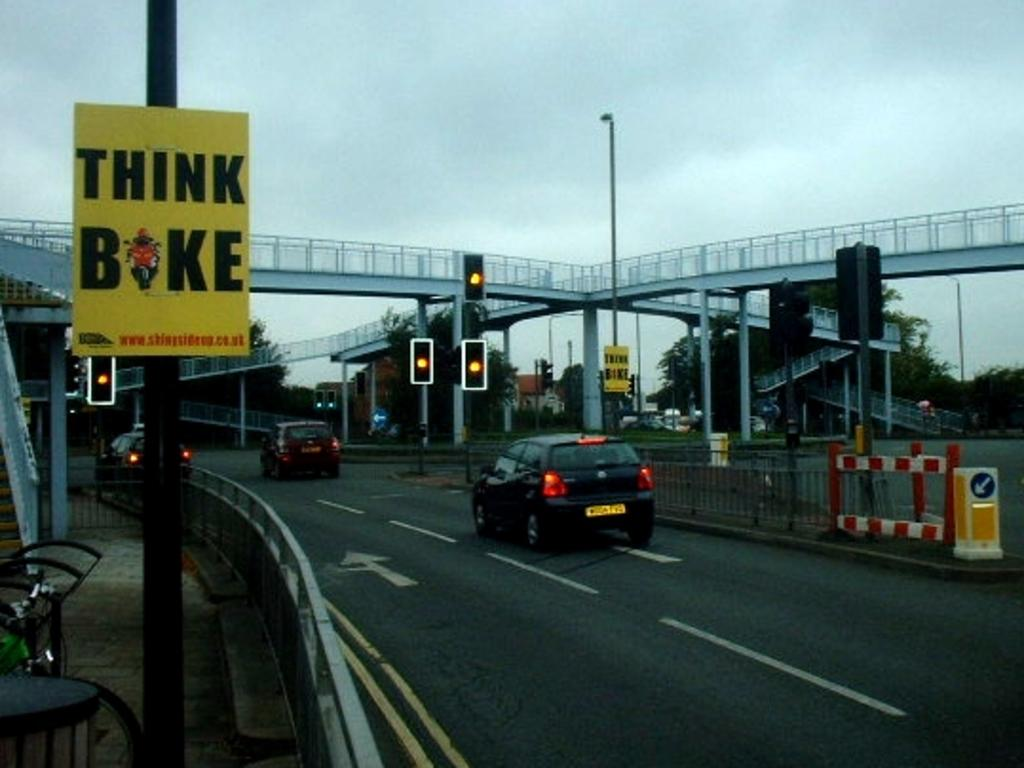What is the main feature of the image? There is a road in the image. What can be seen on the road? There are cars on the road. What structures are present in the image? There are poles, boards, and traffic lights in the image. What type of vegetation is visible in the image? There are trees in the image. What architectural feature is at the top of the image? There is a bridge at the top of the image. What is visible in the sky? The sky is visible at the top of the image. What type of coil can be seen on the bridge in the image? There is no coil present on the bridge in the image. How many spiders are crawling on the cars in the image? There are no spiders visible on the cars in the image. 